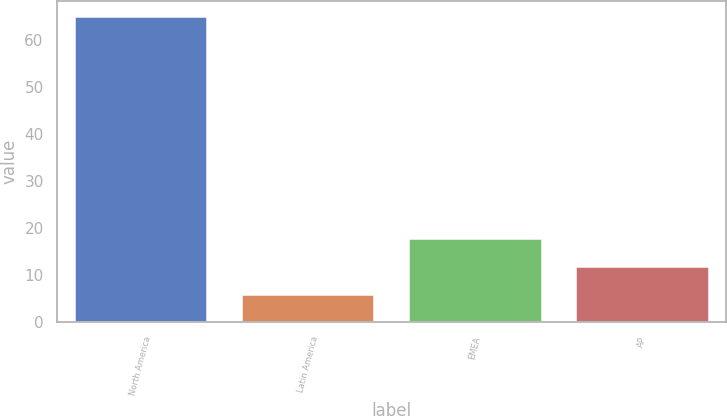Convert chart. <chart><loc_0><loc_0><loc_500><loc_500><bar_chart><fcel>North America<fcel>Latin America<fcel>EMEA<fcel>AP<nl><fcel>65<fcel>6<fcel>17.9<fcel>12<nl></chart> 